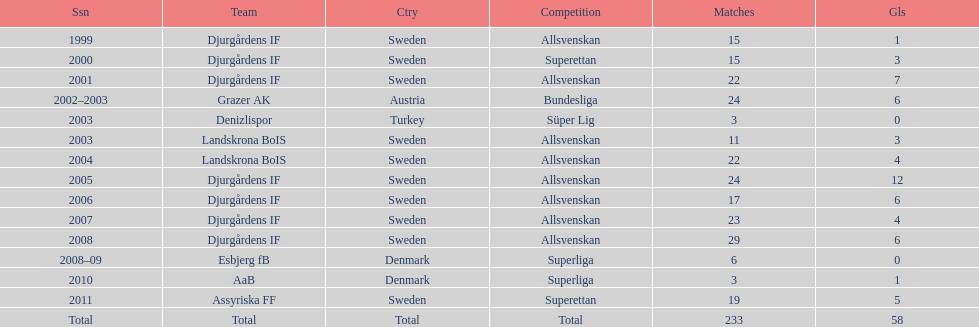What season has the most goals? 2005. 